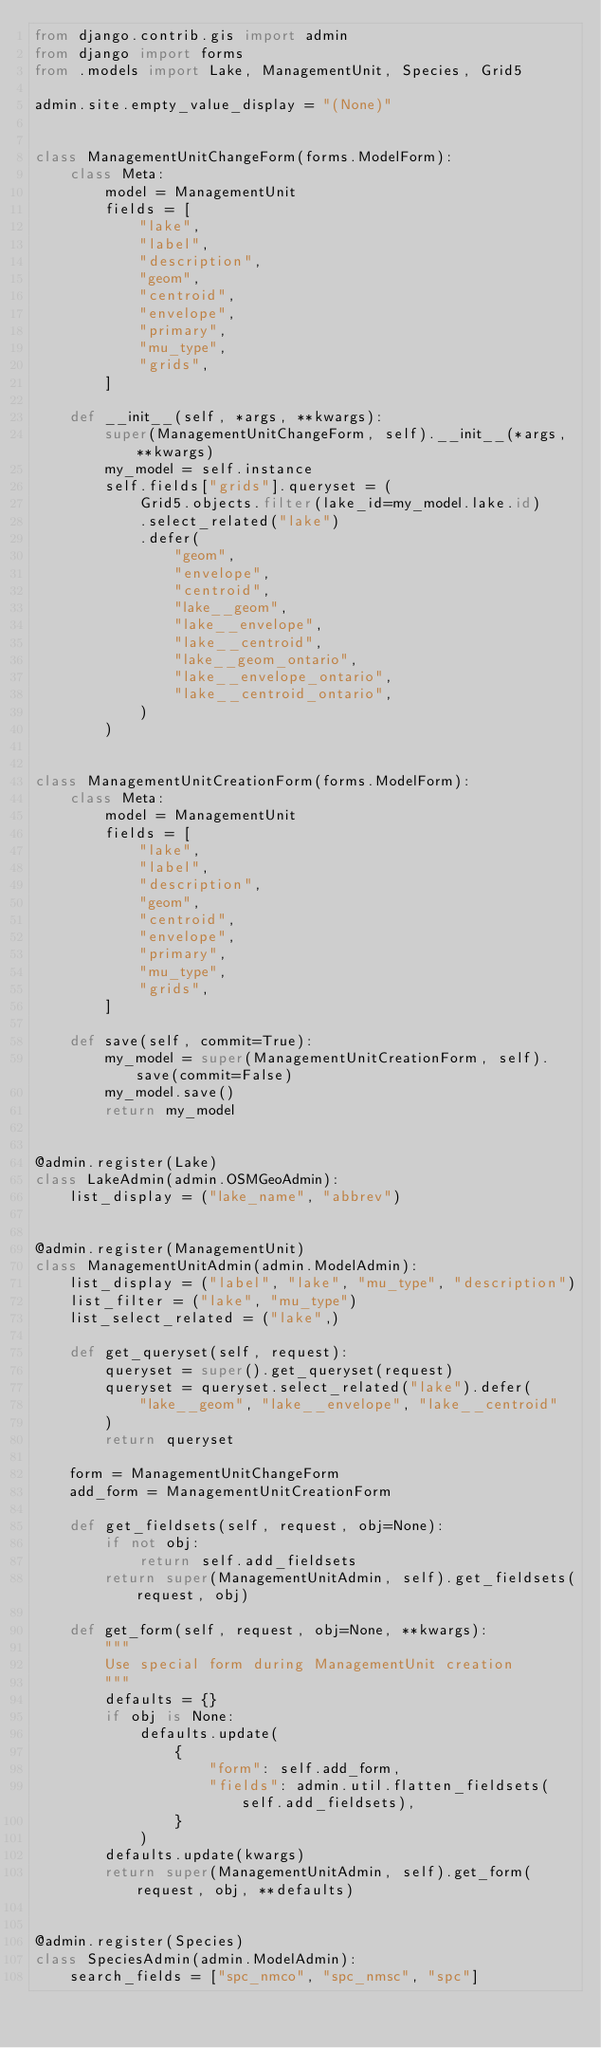<code> <loc_0><loc_0><loc_500><loc_500><_Python_>from django.contrib.gis import admin
from django import forms
from .models import Lake, ManagementUnit, Species, Grid5

admin.site.empty_value_display = "(None)"


class ManagementUnitChangeForm(forms.ModelForm):
    class Meta:
        model = ManagementUnit
        fields = [
            "lake",
            "label",
            "description",
            "geom",
            "centroid",
            "envelope",
            "primary",
            "mu_type",
            "grids",
        ]

    def __init__(self, *args, **kwargs):
        super(ManagementUnitChangeForm, self).__init__(*args, **kwargs)
        my_model = self.instance
        self.fields["grids"].queryset = (
            Grid5.objects.filter(lake_id=my_model.lake.id)
            .select_related("lake")
            .defer(
                "geom",
                "envelope",
                "centroid",
                "lake__geom",
                "lake__envelope",
                "lake__centroid",
                "lake__geom_ontario",
                "lake__envelope_ontario",
                "lake__centroid_ontario",
            )
        )


class ManagementUnitCreationForm(forms.ModelForm):
    class Meta:
        model = ManagementUnit
        fields = [
            "lake",
            "label",
            "description",
            "geom",
            "centroid",
            "envelope",
            "primary",
            "mu_type",
            "grids",
        ]

    def save(self, commit=True):
        my_model = super(ManagementUnitCreationForm, self).save(commit=False)
        my_model.save()
        return my_model


@admin.register(Lake)
class LakeAdmin(admin.OSMGeoAdmin):
    list_display = ("lake_name", "abbrev")


@admin.register(ManagementUnit)
class ManagementUnitAdmin(admin.ModelAdmin):
    list_display = ("label", "lake", "mu_type", "description")
    list_filter = ("lake", "mu_type")
    list_select_related = ("lake",)

    def get_queryset(self, request):
        queryset = super().get_queryset(request)
        queryset = queryset.select_related("lake").defer(
            "lake__geom", "lake__envelope", "lake__centroid"
        )
        return queryset

    form = ManagementUnitChangeForm
    add_form = ManagementUnitCreationForm

    def get_fieldsets(self, request, obj=None):
        if not obj:
            return self.add_fieldsets
        return super(ManagementUnitAdmin, self).get_fieldsets(request, obj)

    def get_form(self, request, obj=None, **kwargs):
        """
        Use special form during ManagementUnit creation
        """
        defaults = {}
        if obj is None:
            defaults.update(
                {
                    "form": self.add_form,
                    "fields": admin.util.flatten_fieldsets(self.add_fieldsets),
                }
            )
        defaults.update(kwargs)
        return super(ManagementUnitAdmin, self).get_form(request, obj, **defaults)


@admin.register(Species)
class SpeciesAdmin(admin.ModelAdmin):
    search_fields = ["spc_nmco", "spc_nmsc", "spc"]</code> 